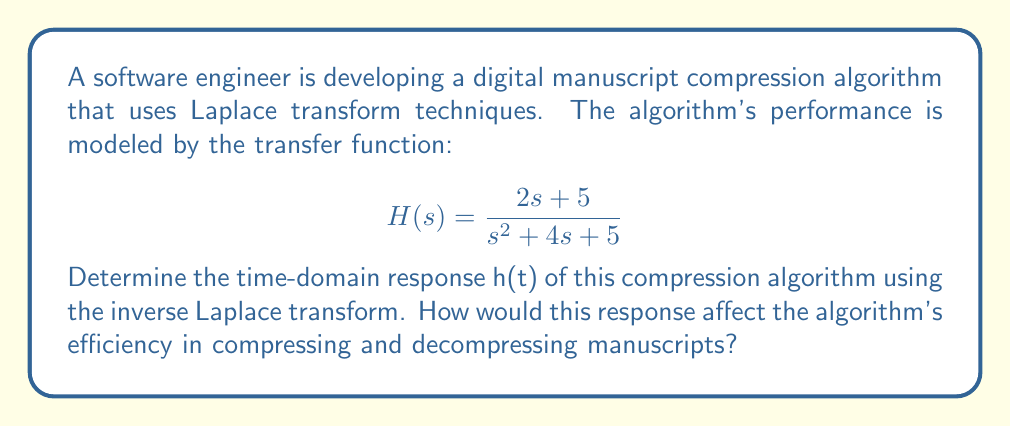Can you answer this question? To solve this problem, we need to apply the inverse Laplace transform to the given transfer function H(s). Let's break it down step by step:

1) First, we need to decompose H(s) into partial fractions:

   $$H(s) = \frac{2s + 5}{s^2 + 4s + 5} = \frac{A}{s + 2 + i} + \frac{B}{s + 2 - i}$$

2) Solving for A and B:

   $$2s + 5 = A(s + 2 - i) + B(s + 2 + i)$$

   Comparing coefficients:
   $s^1: 2 = A + B$
   $s^0: 5 = 2A + 2B - iA + iB$

   Solving these equations:
   $A = 1 - \frac{i}{2}$ and $B = 1 + \frac{i}{2}$

3) Now we can rewrite H(s) as:

   $$H(s) = \frac{1 - \frac{i}{2}}{s + 2 + i} + \frac{1 + \frac{i}{2}}{s + 2 - i}$$

4) We can now apply the inverse Laplace transform. Recall that:

   $$\mathcal{L}^{-1}\left\{\frac{1}{s + a}\right\} = e^{-at}$$

   Therefore:

   $$h(t) = (1 - \frac{i}{2})e^{-(2+i)t} + (1 + \frac{i}{2})e^{-(2-i)t}$$

5) Simplifying:

   $$h(t) = e^{-2t}[(1 - \frac{i}{2})(e^{-it}) + (1 + \frac{i}{2})(e^{it})]$$
   
   $$= e^{-2t}[(1 - \frac{i}{2})(\cos t - i\sin t) + (1 + \frac{i}{2})(\cos t + i\sin t)]$$
   
   $$= e^{-2t}[2\cos t + \sin t]$$

This time-domain response would affect the algorithm's efficiency in the following ways:

1. The exponential decay ($e^{-2t}$) indicates that the algorithm's response diminishes quickly over time, which could lead to efficient compression by reducing the amount of data needed to represent the manuscript over time.

2. The oscillatory behavior ($2\cos t + \sin t$) suggests that the algorithm might introduce some periodic variations in the compressed data, which could potentially affect the quality of the compressed manuscript, especially for texts with repetitive patterns.

3. The combination of decay and oscillation implies that the algorithm might be particularly effective for compressing manuscripts with both long-term trends and short-term variations in content or structure.
Answer: $$h(t) = e^{-2t}[2\cos t + \sin t]$$ 